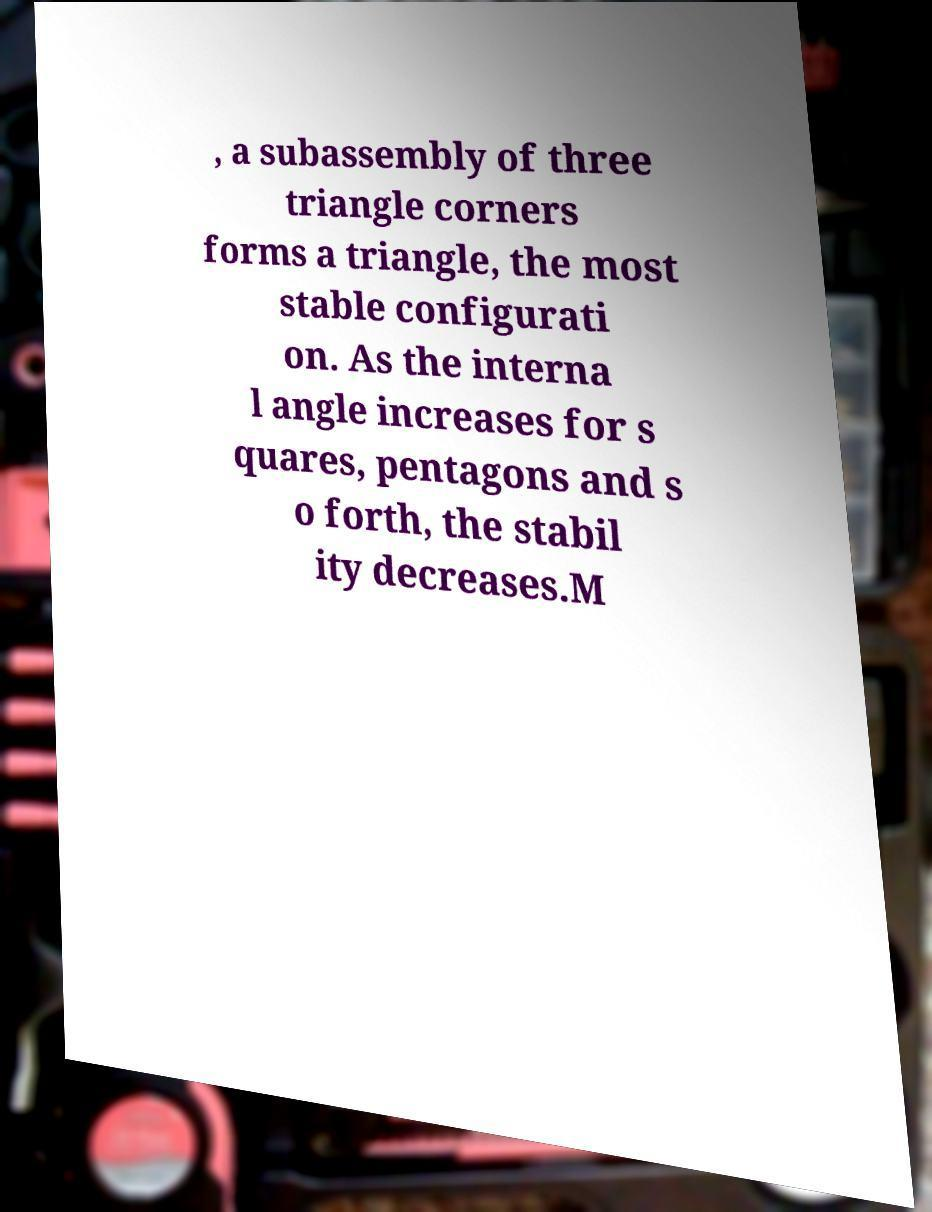Please identify and transcribe the text found in this image. , a subassembly of three triangle corners forms a triangle, the most stable configurati on. As the interna l angle increases for s quares, pentagons and s o forth, the stabil ity decreases.M 